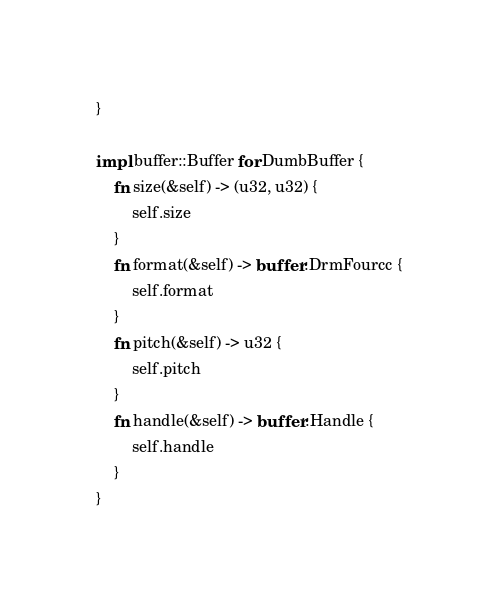Convert code to text. <code><loc_0><loc_0><loc_500><loc_500><_Rust_>}

impl buffer::Buffer for DumbBuffer {
    fn size(&self) -> (u32, u32) {
        self.size
    }
    fn format(&self) -> buffer::DrmFourcc {
        self.format
    }
    fn pitch(&self) -> u32 {
        self.pitch
    }
    fn handle(&self) -> buffer::Handle {
        self.handle
    }
}</code> 